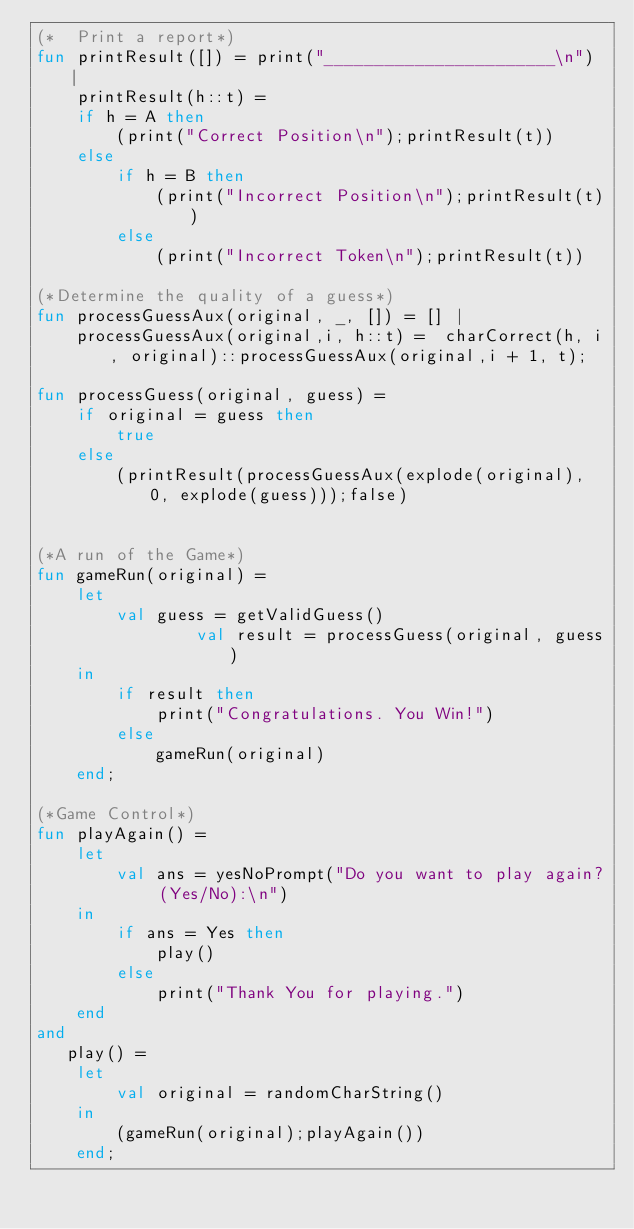Convert code to text. <code><loc_0><loc_0><loc_500><loc_500><_SML_>(*  Print a report*)
fun printResult([]) = print("_______________________\n") |
    printResult(h::t) =
    if h = A then
        (print("Correct Position\n");printResult(t))
    else
        if h = B then
            (print("Incorrect Position\n");printResult(t))
        else
            (print("Incorrect Token\n");printResult(t))

(*Determine the quality of a guess*)
fun processGuessAux(original, _, []) = [] |
    processGuessAux(original,i, h::t) =  charCorrect(h, i, original)::processGuessAux(original,i + 1, t);

fun processGuess(original, guess) =
    if original = guess then
        true
    else
        (printResult(processGuessAux(explode(original), 0, explode(guess)));false)
   

(*A run of the Game*)
fun gameRun(original) =
    let
        val guess = getValidGuess()
                val result = processGuess(original, guess)
    in
        if result then
            print("Congratulations. You Win!")
        else
            gameRun(original)
    end;

(*Game Control*)
fun playAgain() =
    let
        val ans = yesNoPrompt("Do you want to play again? (Yes/No):\n")
    in
        if ans = Yes then
            play()
        else
            print("Thank You for playing.")
    end
and
   play() =
    let
        val original = randomCharString()
    in
        (gameRun(original);playAgain())
    end;
</code> 